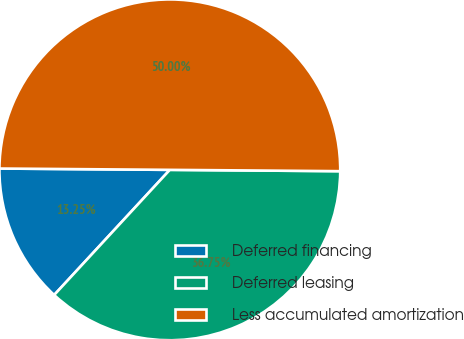Convert chart. <chart><loc_0><loc_0><loc_500><loc_500><pie_chart><fcel>Deferred financing<fcel>Deferred leasing<fcel>Less accumulated amortization<nl><fcel>13.25%<fcel>36.75%<fcel>50.0%<nl></chart> 